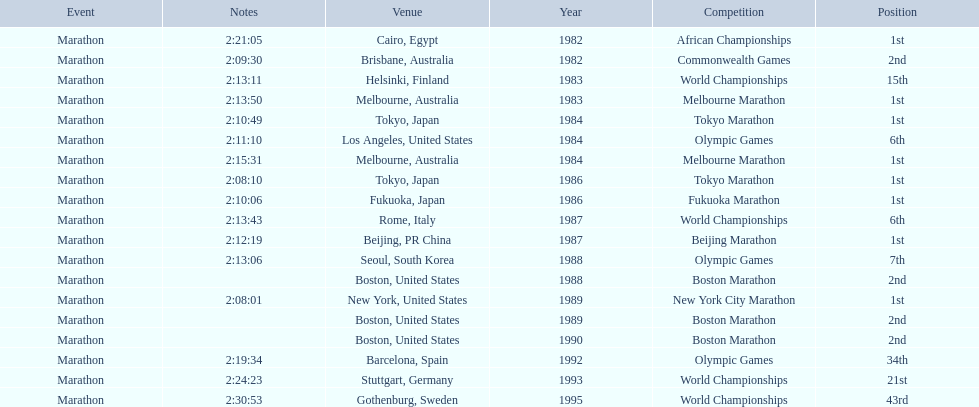What are the competitions? African Championships, Cairo, Egypt, Commonwealth Games, Brisbane, Australia, World Championships, Helsinki, Finland, Melbourne Marathon, Melbourne, Australia, Tokyo Marathon, Tokyo, Japan, Olympic Games, Los Angeles, United States, Melbourne Marathon, Melbourne, Australia, Tokyo Marathon, Tokyo, Japan, Fukuoka Marathon, Fukuoka, Japan, World Championships, Rome, Italy, Beijing Marathon, Beijing, PR China, Olympic Games, Seoul, South Korea, Boston Marathon, Boston, United States, New York City Marathon, New York, United States, Boston Marathon, Boston, United States, Boston Marathon, Boston, United States, Olympic Games, Barcelona, Spain, World Championships, Stuttgart, Germany, World Championships, Gothenburg, Sweden. Help me parse the entirety of this table. {'header': ['Event', 'Notes', 'Venue', 'Year', 'Competition', 'Position'], 'rows': [['Marathon', '2:21:05', 'Cairo, Egypt', '1982', 'African Championships', '1st'], ['Marathon', '2:09:30', 'Brisbane, Australia', '1982', 'Commonwealth Games', '2nd'], ['Marathon', '2:13:11', 'Helsinki, Finland', '1983', 'World Championships', '15th'], ['Marathon', '2:13:50', 'Melbourne, Australia', '1983', 'Melbourne Marathon', '1st'], ['Marathon', '2:10:49', 'Tokyo, Japan', '1984', 'Tokyo Marathon', '1st'], ['Marathon', '2:11:10', 'Los Angeles, United States', '1984', 'Olympic Games', '6th'], ['Marathon', '2:15:31', 'Melbourne, Australia', '1984', 'Melbourne Marathon', '1st'], ['Marathon', '2:08:10', 'Tokyo, Japan', '1986', 'Tokyo Marathon', '1st'], ['Marathon', '2:10:06', 'Fukuoka, Japan', '1986', 'Fukuoka Marathon', '1st'], ['Marathon', '2:13:43', 'Rome, Italy', '1987', 'World Championships', '6th'], ['Marathon', '2:12:19', 'Beijing, PR China', '1987', 'Beijing Marathon', '1st'], ['Marathon', '2:13:06', 'Seoul, South Korea', '1988', 'Olympic Games', '7th'], ['Marathon', '', 'Boston, United States', '1988', 'Boston Marathon', '2nd'], ['Marathon', '2:08:01', 'New York, United States', '1989', 'New York City Marathon', '1st'], ['Marathon', '', 'Boston, United States', '1989', 'Boston Marathon', '2nd'], ['Marathon', '', 'Boston, United States', '1990', 'Boston Marathon', '2nd'], ['Marathon', '2:19:34', 'Barcelona, Spain', '1992', 'Olympic Games', '34th'], ['Marathon', '2:24:23', 'Stuttgart, Germany', '1993', 'World Championships', '21st'], ['Marathon', '2:30:53', 'Gothenburg, Sweden', '1995', 'World Championships', '43rd']]} Which ones occured in china? Beijing Marathon, Beijing, PR China. Which one is it? Beijing Marathon. 